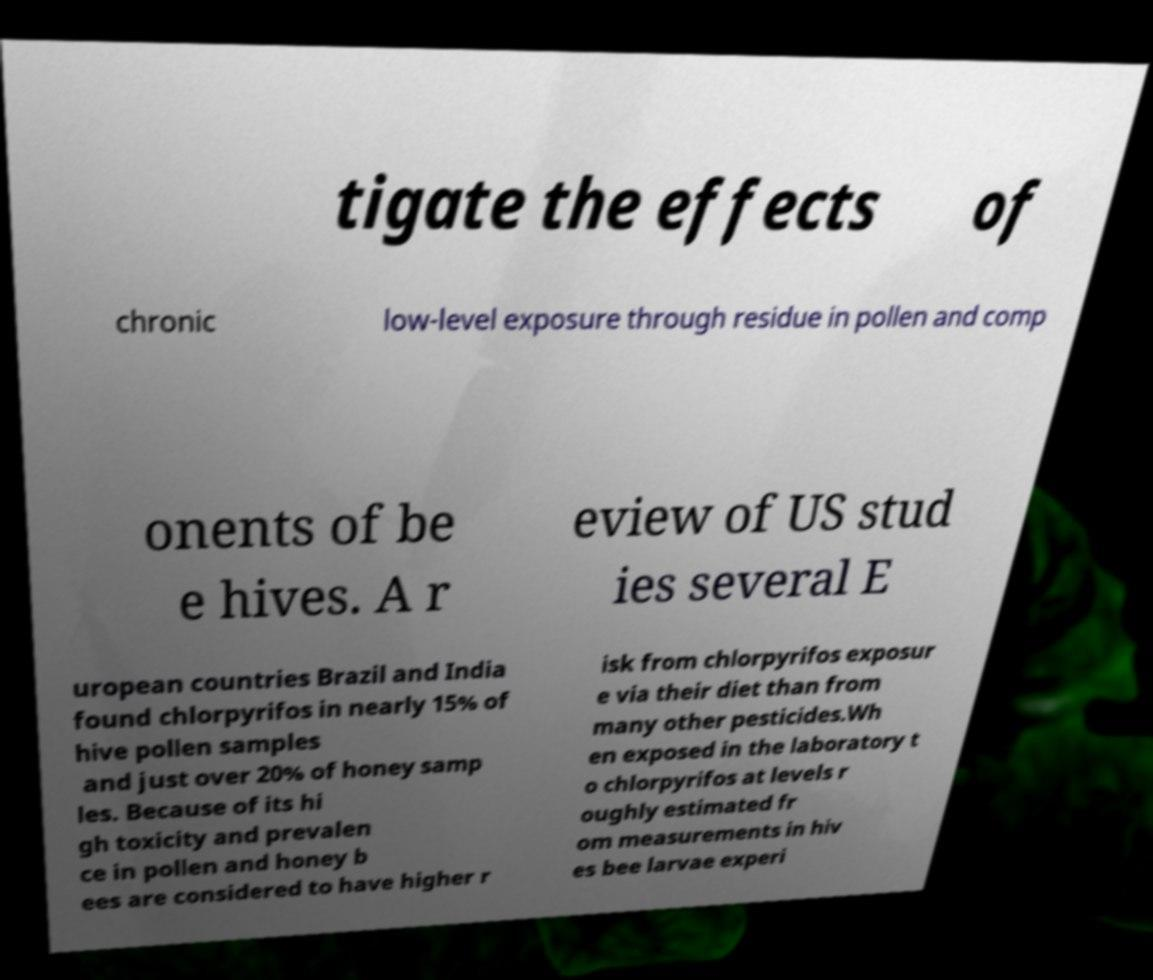Can you accurately transcribe the text from the provided image for me? tigate the effects of chronic low-level exposure through residue in pollen and comp onents of be e hives. A r eview of US stud ies several E uropean countries Brazil and India found chlorpyrifos in nearly 15% of hive pollen samples and just over 20% of honey samp les. Because of its hi gh toxicity and prevalen ce in pollen and honey b ees are considered to have higher r isk from chlorpyrifos exposur e via their diet than from many other pesticides.Wh en exposed in the laboratory t o chlorpyrifos at levels r oughly estimated fr om measurements in hiv es bee larvae experi 